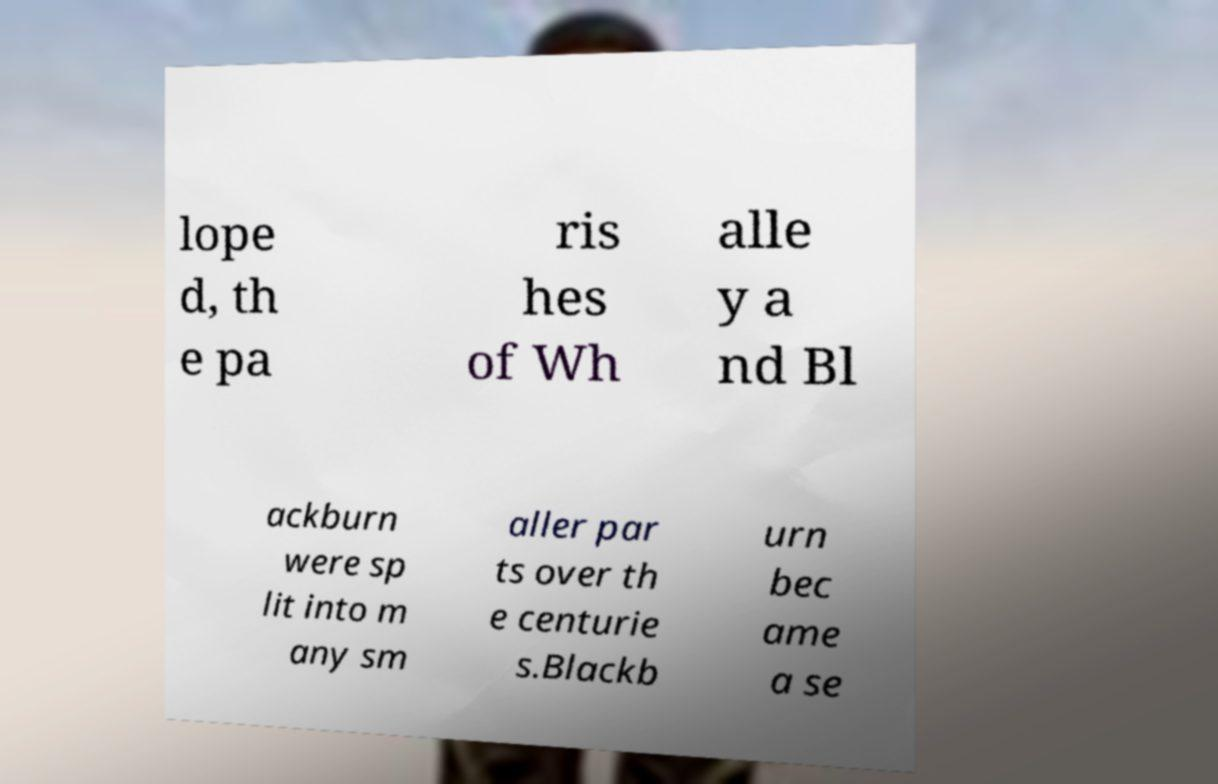Could you extract and type out the text from this image? lope d, th e pa ris hes of Wh alle y a nd Bl ackburn were sp lit into m any sm aller par ts over th e centurie s.Blackb urn bec ame a se 